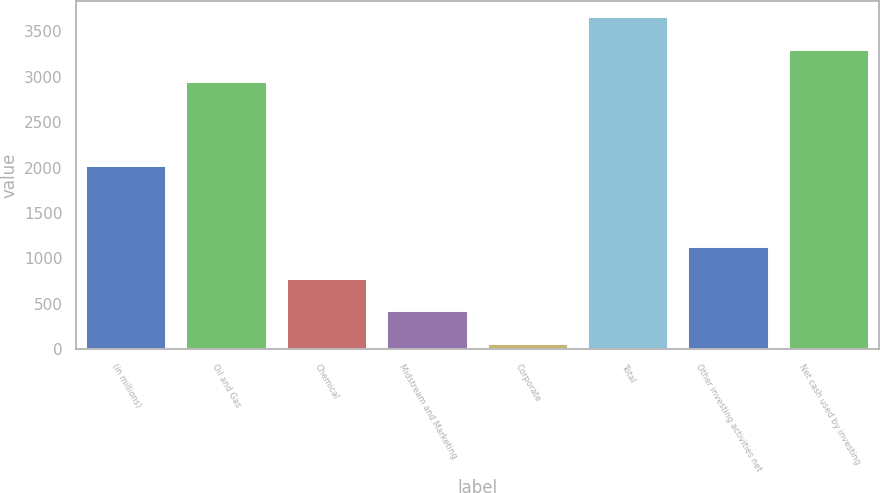Convert chart to OTSL. <chart><loc_0><loc_0><loc_500><loc_500><bar_chart><fcel>(in millions)<fcel>Oil and Gas<fcel>Chemical<fcel>Midstream and Marketing<fcel>Corporate<fcel>Total<fcel>Other investing activities net<fcel>Net cash used by investing<nl><fcel>2017<fcel>2945<fcel>769.4<fcel>415.7<fcel>62<fcel>3652.4<fcel>1123.1<fcel>3298.7<nl></chart> 